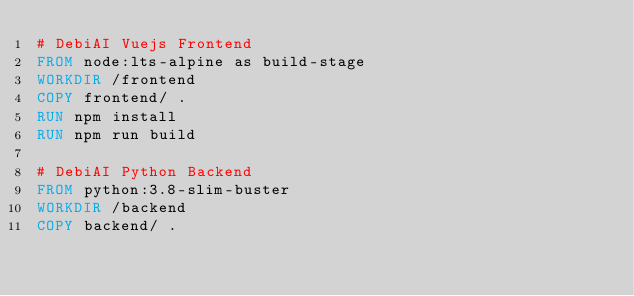Convert code to text. <code><loc_0><loc_0><loc_500><loc_500><_Dockerfile_># DebiAI Vuejs Frontend
FROM node:lts-alpine as build-stage
WORKDIR /frontend
COPY frontend/ .
RUN npm install
RUN npm run build

# DebiAI Python Backend
FROM python:3.8-slim-buster
WORKDIR /backend
COPY backend/ .</code> 